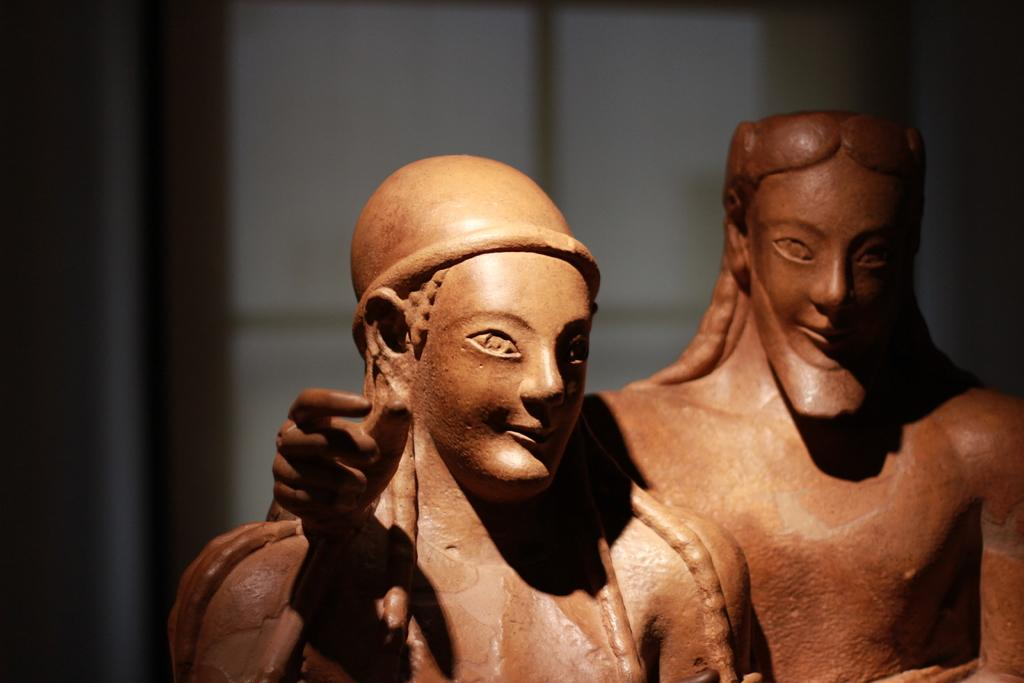What is: What is the main subject in the image? There is a statue in the image. Can you describe the statue on the right side of the image? There is a man on the right side of the image. What is the statue on the left side of the image? There is a woman's statue on the left side of the image. What can be seen in the background of the image? There is a window in the background of the image. What type of company does the man on the right side of the image work for? There is no information about the man's job or company in the image. 